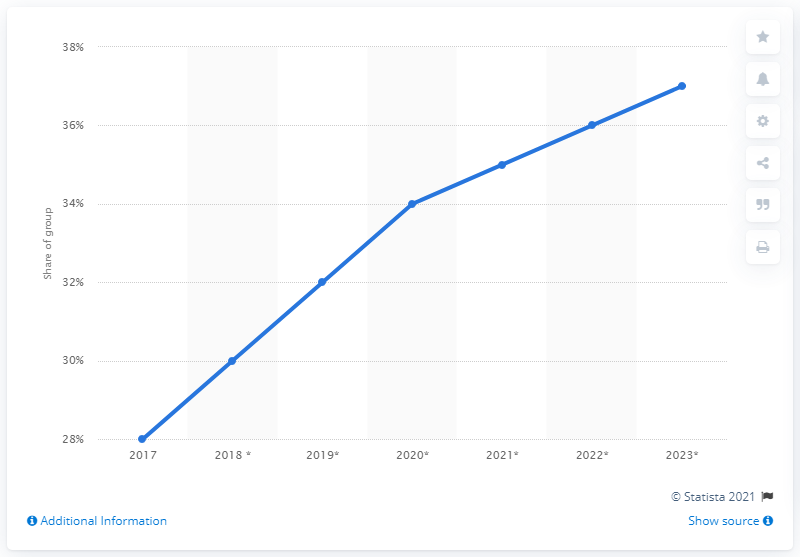Mention a couple of crucial points in this snapshot. According to projections, in 2019, it is expected that Indonesians will account for approximately 32% of the global social media usage. 